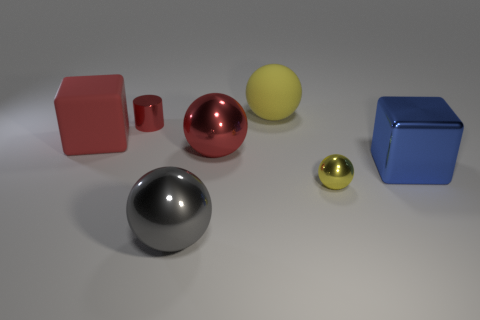Subtract all yellow cylinders. How many yellow spheres are left? 2 Subtract all large gray metal spheres. How many spheres are left? 3 Add 3 small cyan things. How many objects exist? 10 Subtract 2 balls. How many balls are left? 2 Subtract all yellow spheres. How many spheres are left? 2 Subtract all blocks. How many objects are left? 5 Add 5 small gray cubes. How many small gray cubes exist? 5 Subtract 0 purple cubes. How many objects are left? 7 Subtract all green spheres. Subtract all red cylinders. How many spheres are left? 4 Subtract all large gray shiny balls. Subtract all matte balls. How many objects are left? 5 